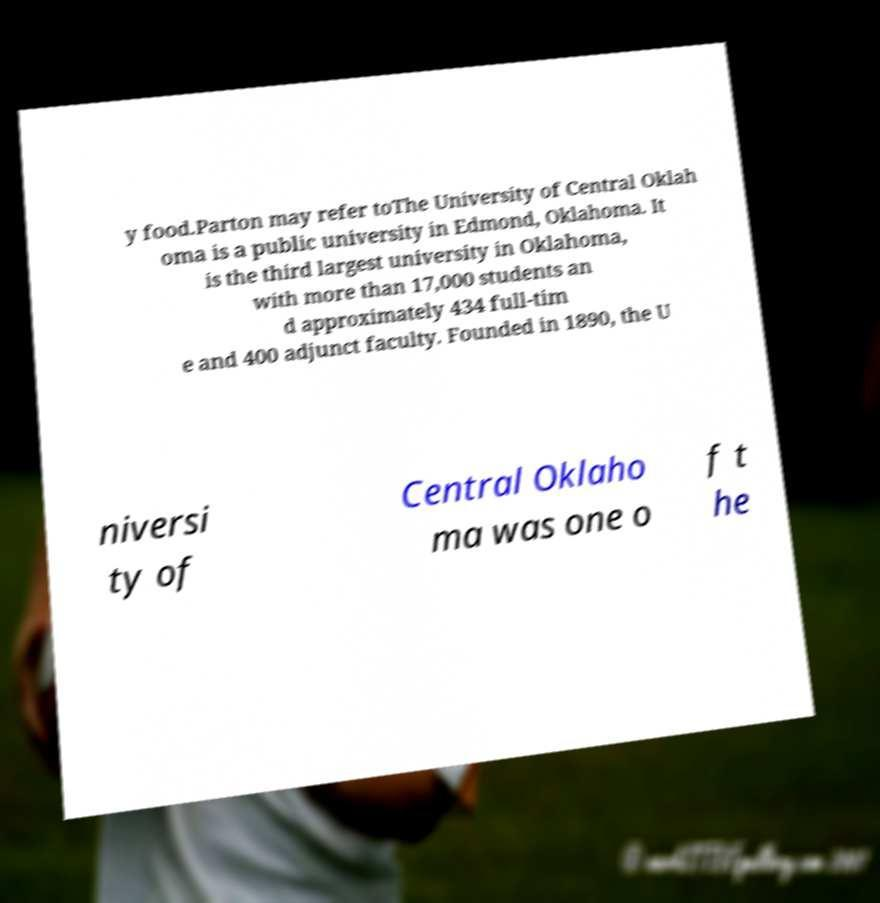There's text embedded in this image that I need extracted. Can you transcribe it verbatim? y food.Parton may refer toThe University of Central Oklah oma is a public university in Edmond, Oklahoma. It is the third largest university in Oklahoma, with more than 17,000 students an d approximately 434 full-tim e and 400 adjunct faculty. Founded in 1890, the U niversi ty of Central Oklaho ma was one o f t he 